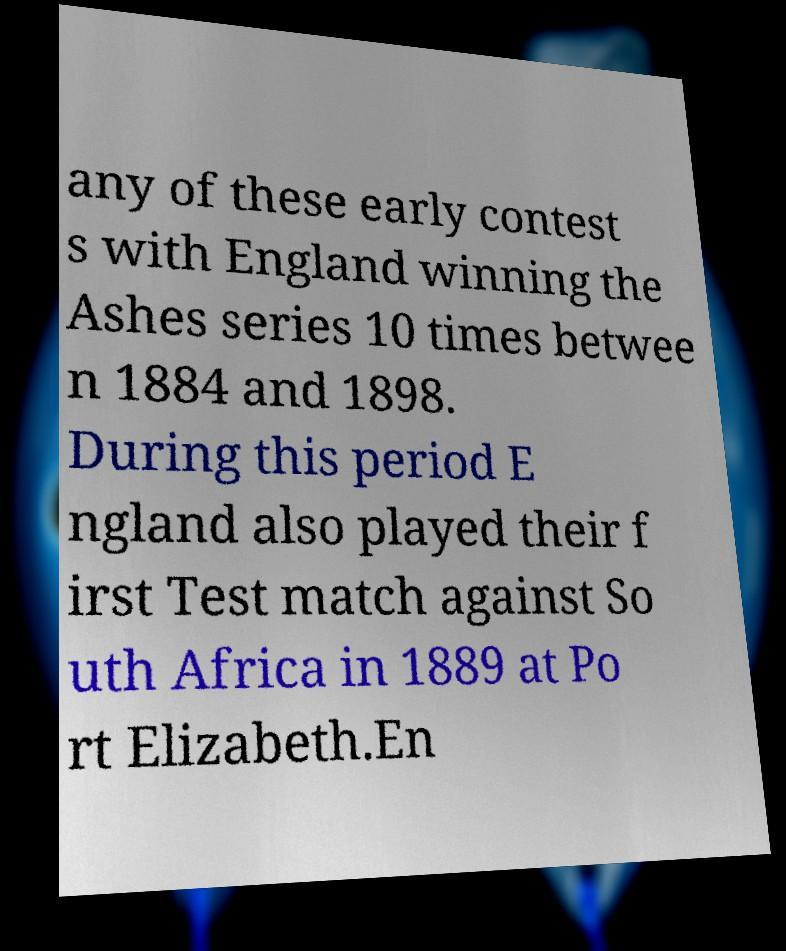Can you read and provide the text displayed in the image?This photo seems to have some interesting text. Can you extract and type it out for me? any of these early contest s with England winning the Ashes series 10 times betwee n 1884 and 1898. During this period E ngland also played their f irst Test match against So uth Africa in 1889 at Po rt Elizabeth.En 